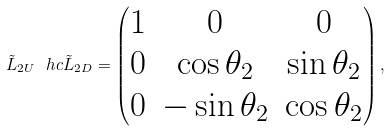Convert formula to latex. <formula><loc_0><loc_0><loc_500><loc_500>\tilde { L } _ { 2 U } \ h c \tilde { L } _ { 2 D } = \begin{pmatrix} 1 & 0 & 0 \\ 0 & \cos \theta _ { 2 } & \sin \theta _ { 2 } \\ 0 & - \sin \theta _ { 2 } & \cos \theta _ { 2 } \end{pmatrix} ,</formula> 